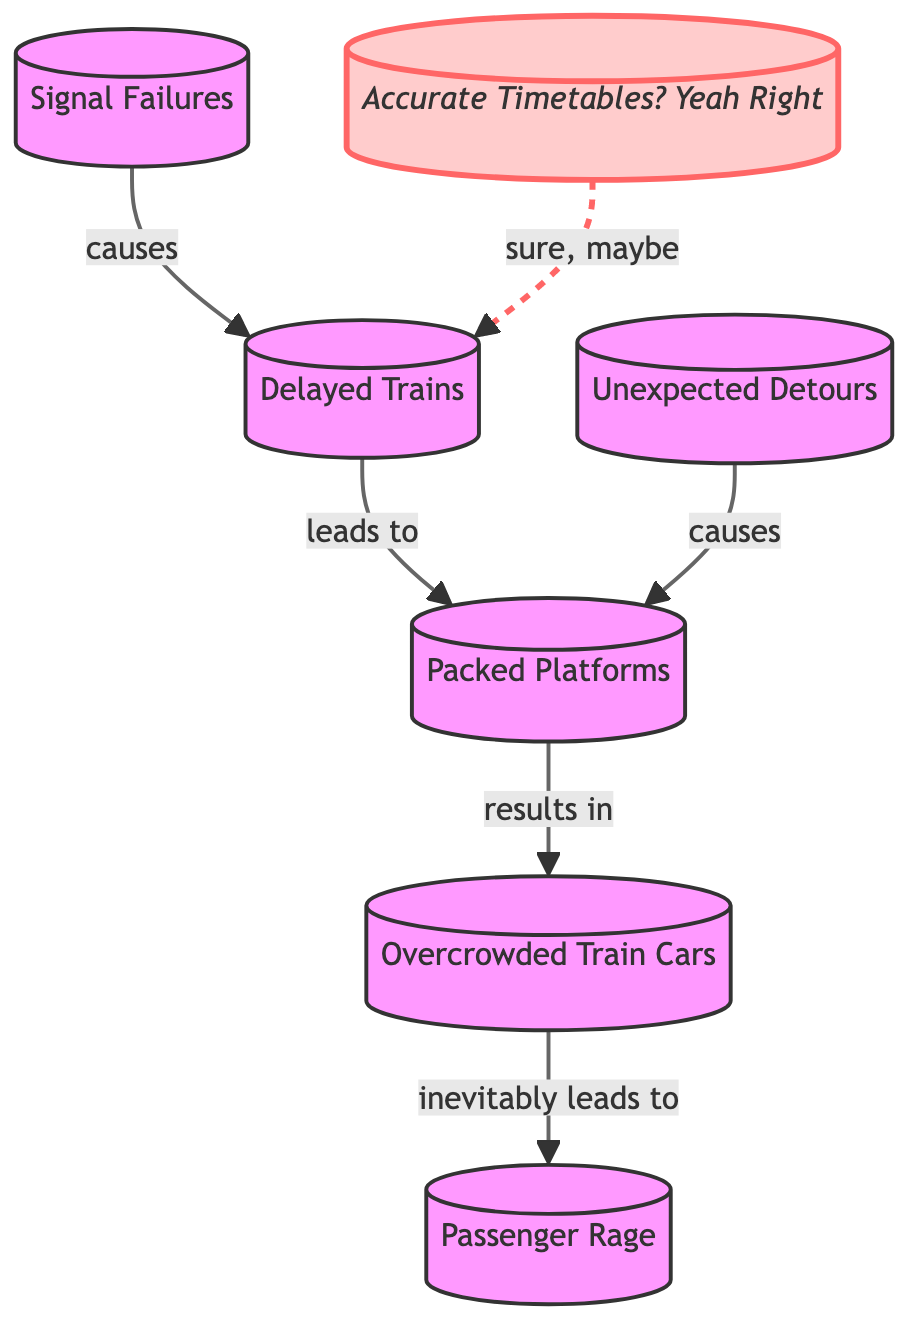What are the causes of Delayed Trains? In the diagram, Delayed Trains are caused by Signal Failures. The arrow labeled "causes" connects Signal Failures directly to Delayed Trains, indicating this is a causal relationship.
Answer: Signal Failures How many nodes are shown in the diagram? By counting each unique labeled circle in the diagram, we find there are seven nodes: Delayed Trains, Packed Platforms, Overcrowded Train Cars, Signal Failures, Unexpected Detours, Accurate Timetables? Yeah Right, and Passenger Rage.
Answer: seven What leads to Overcrowded Train Cars? In the diagram, Overcrowded Train Cars are a result of Packed Platforms. The arrow labeled "results in" indicates that Packed Platforms directly lead to Overcrowded Train Cars.
Answer: Packed Platforms What is the relationship between Unexpected Detours and Packed Platforms? The diagram shows that Unexpected Detours cause Packed Platforms. The arrow labeled "causes" connects Unexpected Detours directly to Packed Platforms, indicating a direct causal relationship.
Answer: causes Which node has a cynical label style? The node with the label "Accurate Timetables? Yeah Right" is the only node that has the distinctive cynical style indicated by the class definition.
Answer: Accurate Timetables? Yeah Right Which node is the final outcome in the sequence? The final outcome in the sequence is Passenger Rage. It appears last in the flow of the diagram and is shown to be the inevitable result of Overcrowded Train Cars.
Answer: Passenger Rage What does Accurate Timetables? Yeah Right indirectly lead to? While Accurate Timetables? Yeah Right is not directly connected, it has a dashed line indicating it has an indirect influence on Delayed Trains, suggesting that it affects the situation but does not cause it directly.
Answer: Delayed Trains How many causal relationships are represented in the diagram? The diagram features five causal relationships indicated by solid arrows connecting various nodes, showing the flow from one issue to the next.
Answer: five What results from Signal Failures? The diagram indicates that Signal Failures cause Delayed Trains, suggesting that issues with signals lead directly to the occurrence of delays.
Answer: Delayed Trains 